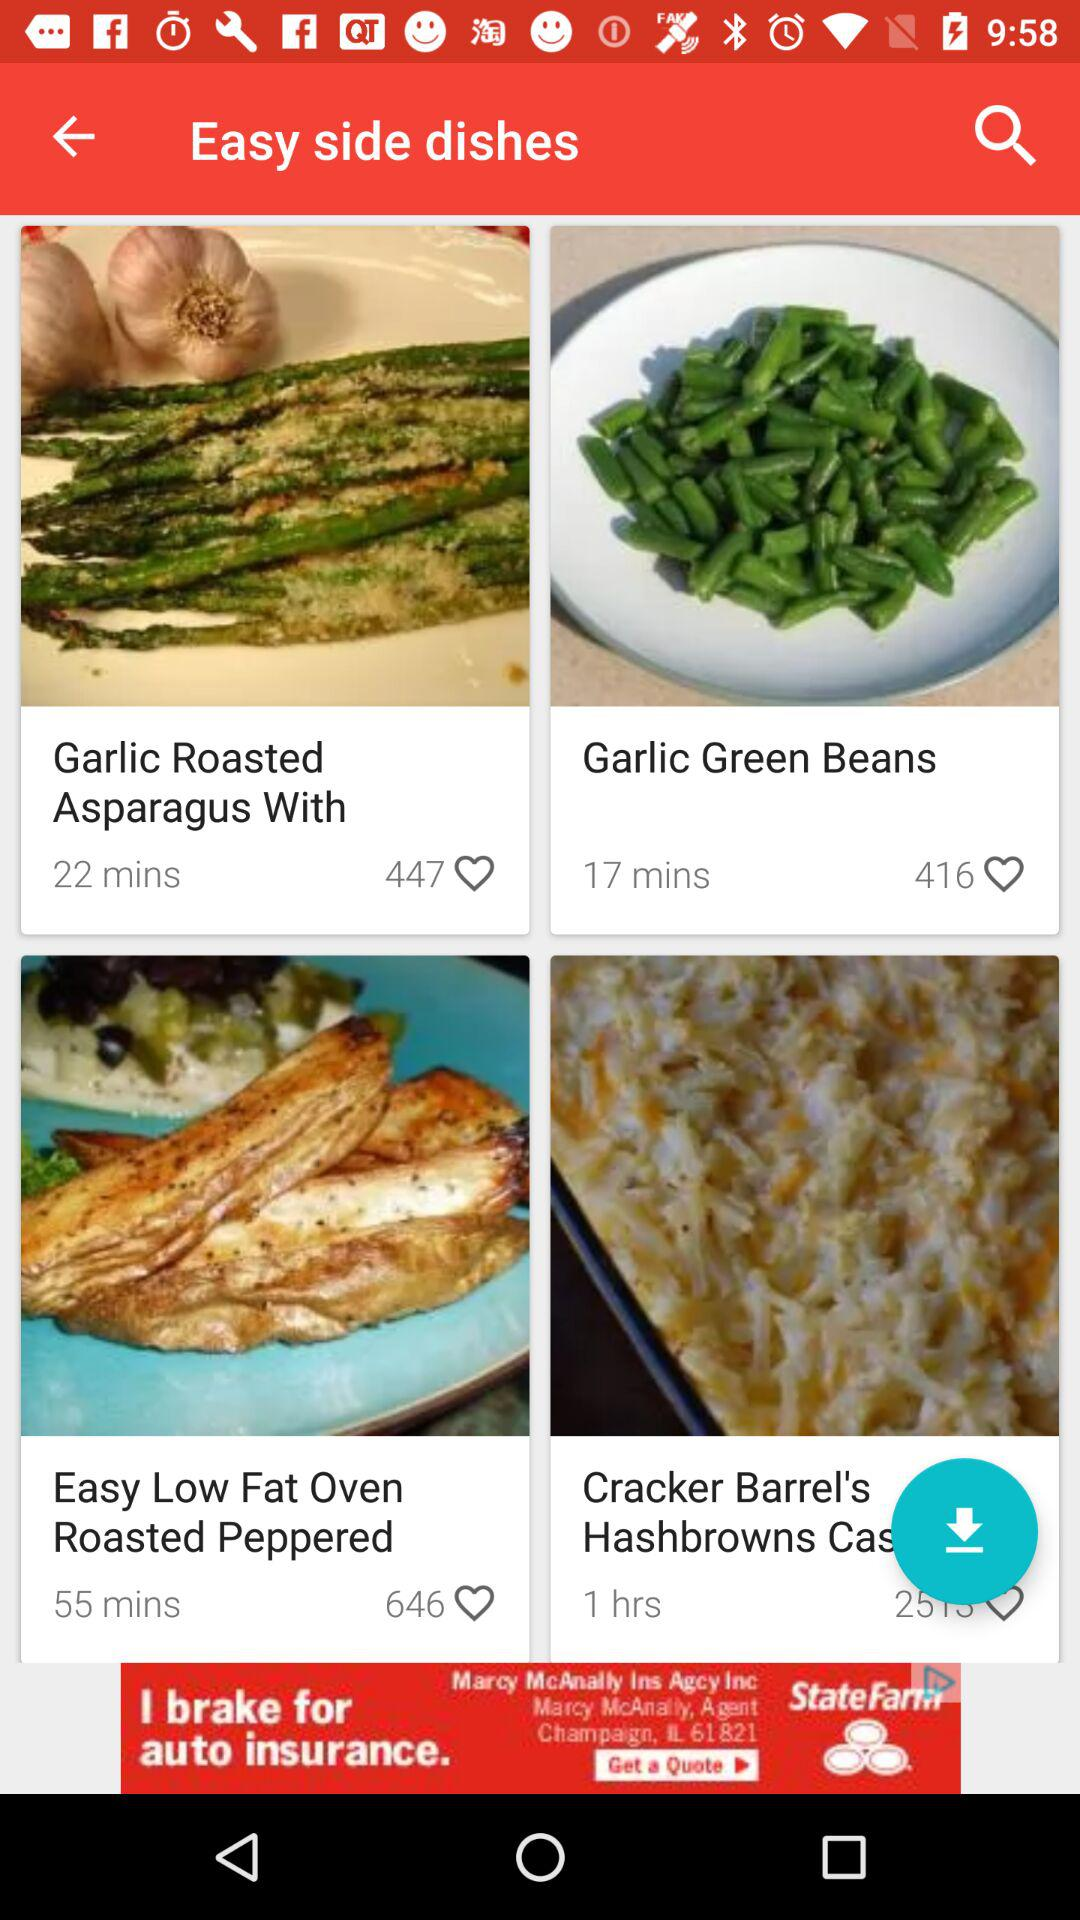How many likes are there for "Garlic Roasted Asparagus"? There are 447 likes. 